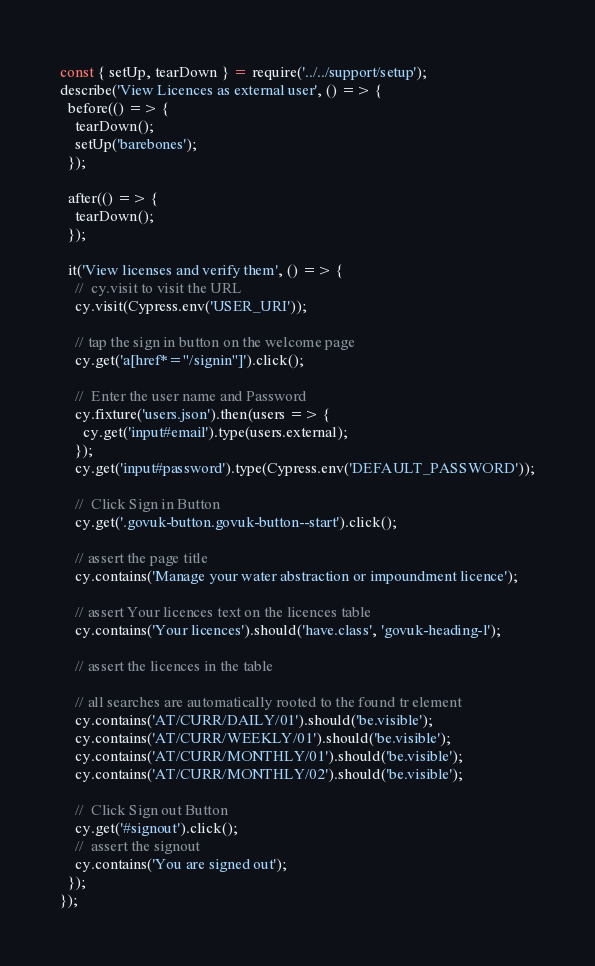Convert code to text. <code><loc_0><loc_0><loc_500><loc_500><_JavaScript_>const { setUp, tearDown } = require('../../support/setup');
describe('View Licences as external user', () => {
  before(() => {
    tearDown();
    setUp('barebones');
  });

  after(() => {
    tearDown();
  });

  it('View licenses and verify them', () => {
    //  cy.visit to visit the URL
    cy.visit(Cypress.env('USER_URI'));

    // tap the sign in button on the welcome page
    cy.get('a[href*="/signin"]').click();

    //  Enter the user name and Password
    cy.fixture('users.json').then(users => {
      cy.get('input#email').type(users.external);
    });
    cy.get('input#password').type(Cypress.env('DEFAULT_PASSWORD'));

    //  Click Sign in Button
    cy.get('.govuk-button.govuk-button--start').click();

    // assert the page title
    cy.contains('Manage your water abstraction or impoundment licence');

    // assert Your licences text on the licences table
    cy.contains('Your licences').should('have.class', 'govuk-heading-l');

    // assert the licences in the table

    // all searches are automatically rooted to the found tr element
    cy.contains('AT/CURR/DAILY/01').should('be.visible');
    cy.contains('AT/CURR/WEEKLY/01').should('be.visible');
    cy.contains('AT/CURR/MONTHLY/01').should('be.visible');
    cy.contains('AT/CURR/MONTHLY/02').should('be.visible');

    //  Click Sign out Button
    cy.get('#signout').click();
    //  assert the signout
    cy.contains('You are signed out');
  });
});
</code> 